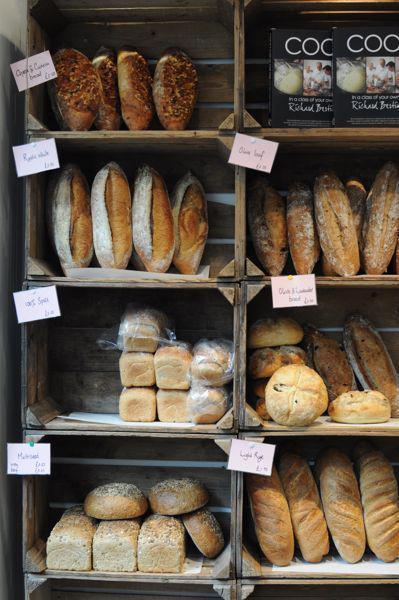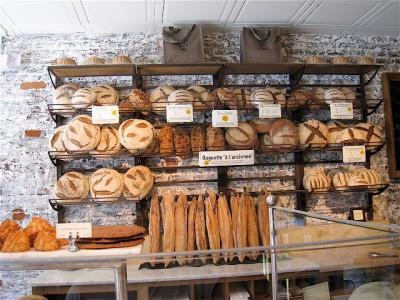The first image is the image on the left, the second image is the image on the right. Assess this claim about the two images: "Both images contain labels and prices.". Correct or not? Answer yes or no. Yes. 